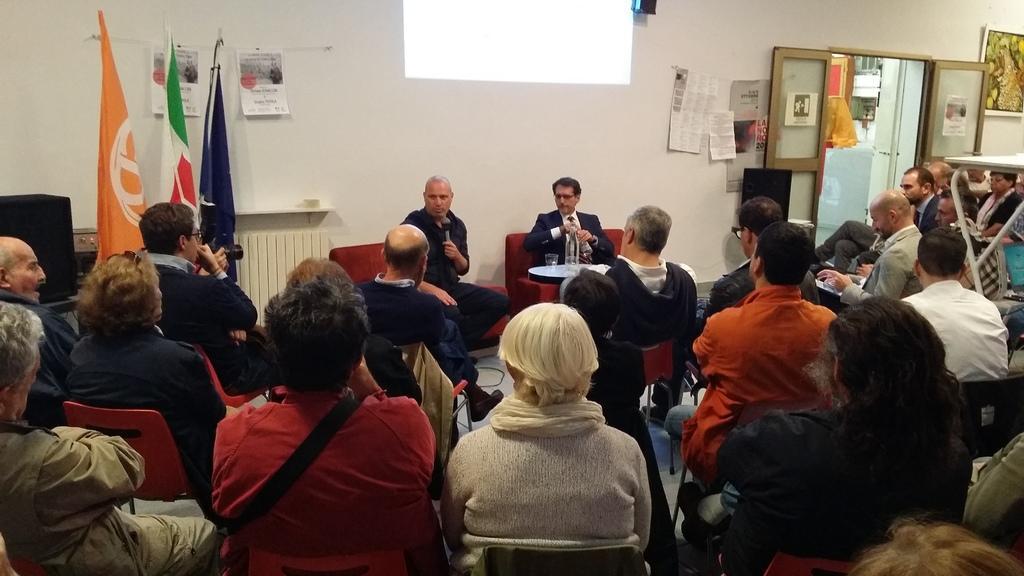Could you give a brief overview of what you see in this image? In this image I can see number of persons are sitting on chairs which are red in color and I can see few persons sitting on couches wearing black colored dresses. I can see one of the person is holding a microphone in his hand. In the background I can see the white colored wall, few papers attached to the wall, few flags, the door, a photo frame and few posters attached to the wall. 